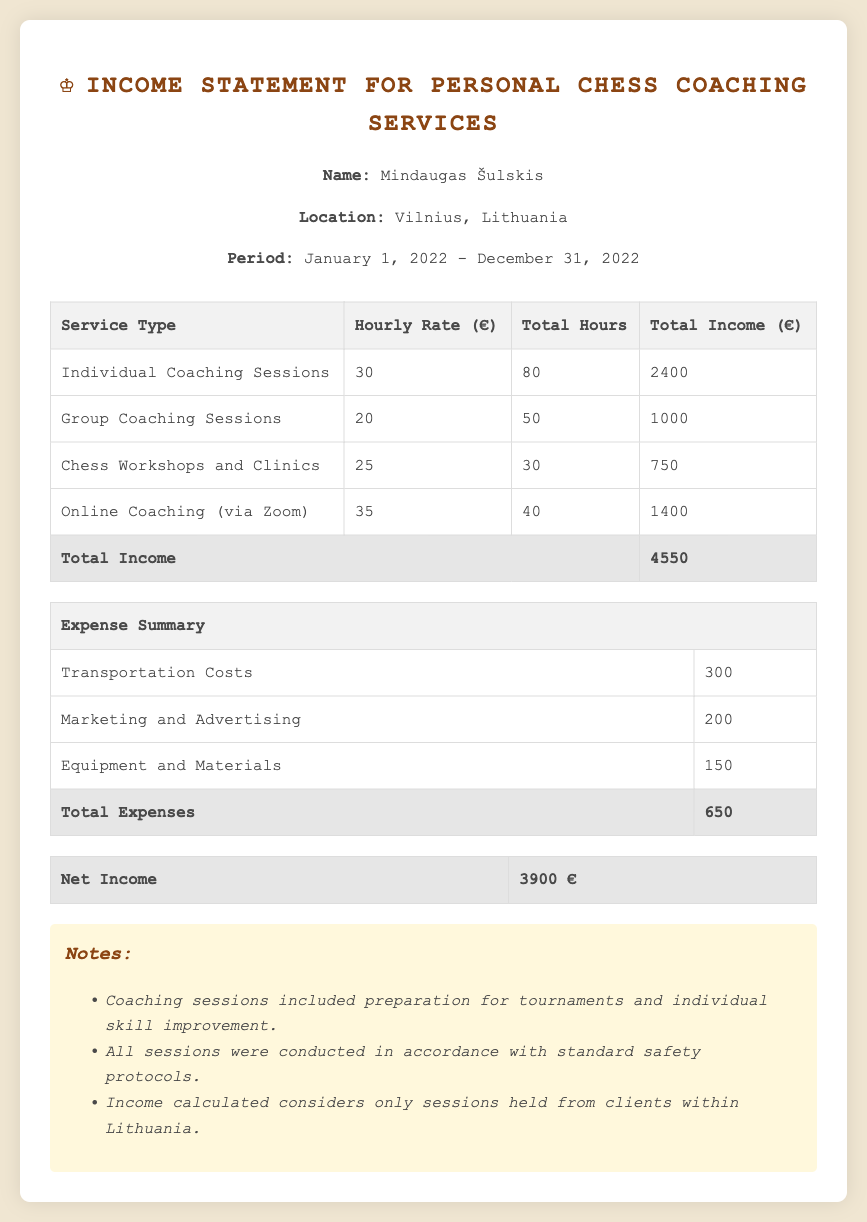What is the total income from individual coaching sessions? The total income from individual coaching sessions is provided in the table under "Total Income" for that service type, which is 2400 euros.
Answer: 2400 How many total hours were worked for group coaching sessions? The total hours for group coaching sessions is mentioned in the table under "Total Hours" for that service type, which is 50 hours.
Answer: 50 What is the hourly rate for online coaching? The hourly rate for online coaching is specified in the table under "Hourly Rate" for that service type, which is 35 euros.
Answer: 35 What were the total expenses listed in the document? The total expenses are calculated and displayed in the table under "Total Expenses," which is the sum of all expenses in that section, totaling 650 euros.
Answer: 650 What is the net income shown in the statement? The net income is presented at the bottom of the expense summary section as the final figure after expenses are deducted, which is 3900 euros.
Answer: 3900 How many chess workshops and clinics were conducted? The total hours worked for chess workshops and clinics can be found in the service table, under "Total Hours" for that service type, which is 30 hours.
Answer: 30 What service type generated the most income? The document specifies that the income from individual coaching sessions yielded the highest total income according to the service income table.
Answer: Individual Coaching Sessions What are the transportation costs listed as an expense? The transportation costs are explicitly listed in the expense summary, denoting a specific line item with an associated amount, which is 300 euros.
Answer: 300 What is the location of the service provider? The location of the service provider is stated in the header information section of the document as Vilnius, Lithuania.
Answer: Vilnius, Lithuania 